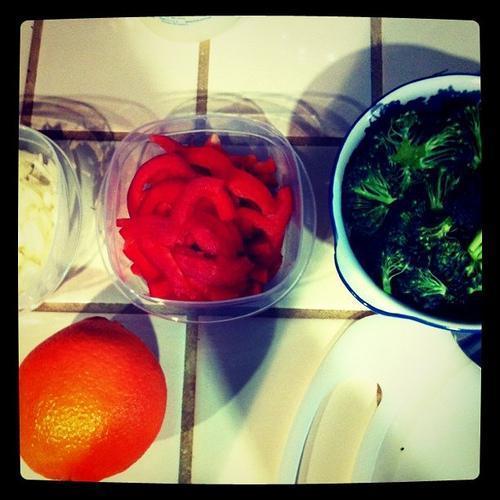How many oranges are there?
Give a very brief answer. 1. 